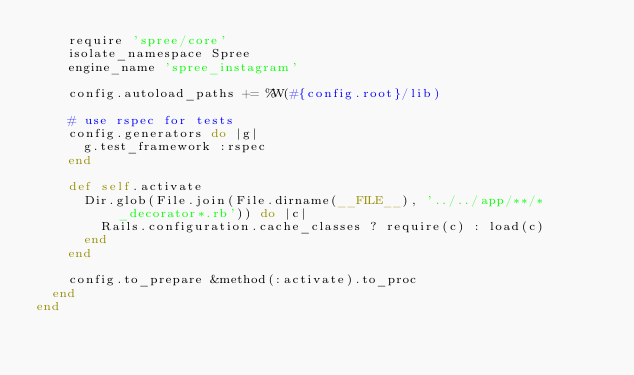Convert code to text. <code><loc_0><loc_0><loc_500><loc_500><_Ruby_>    require 'spree/core'
    isolate_namespace Spree
    engine_name 'spree_instagram'

    config.autoload_paths += %W(#{config.root}/lib)

    # use rspec for tests
    config.generators do |g|
      g.test_framework :rspec
    end

    def self.activate
      Dir.glob(File.join(File.dirname(__FILE__), '../../app/**/*_decorator*.rb')) do |c|
        Rails.configuration.cache_classes ? require(c) : load(c)
      end
    end

    config.to_prepare &method(:activate).to_proc
  end
end
</code> 